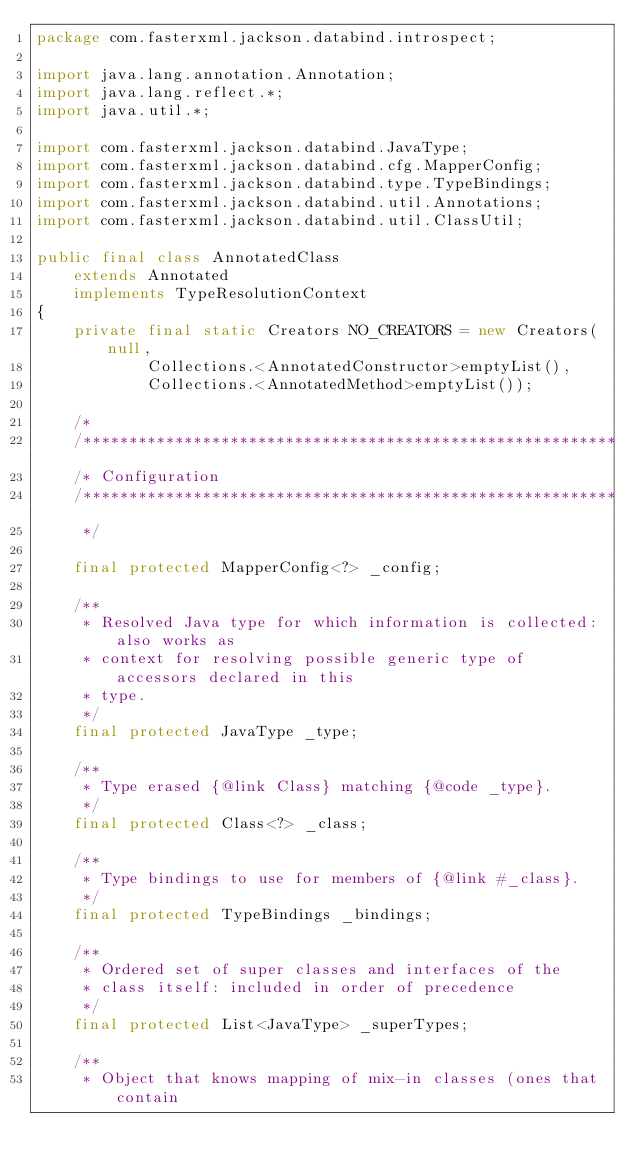Convert code to text. <code><loc_0><loc_0><loc_500><loc_500><_Java_>package com.fasterxml.jackson.databind.introspect;

import java.lang.annotation.Annotation;
import java.lang.reflect.*;
import java.util.*;

import com.fasterxml.jackson.databind.JavaType;
import com.fasterxml.jackson.databind.cfg.MapperConfig;
import com.fasterxml.jackson.databind.type.TypeBindings;
import com.fasterxml.jackson.databind.util.Annotations;
import com.fasterxml.jackson.databind.util.ClassUtil;

public final class AnnotatedClass
    extends Annotated
    implements TypeResolutionContext
{
    private final static Creators NO_CREATORS = new Creators(null,
            Collections.<AnnotatedConstructor>emptyList(),
            Collections.<AnnotatedMethod>emptyList());

    /*
    /**********************************************************
    /* Configuration
    /**********************************************************
     */

    final protected MapperConfig<?> _config;

    /**
     * Resolved Java type for which information is collected: also works as
     * context for resolving possible generic type of accessors declared in this
     * type.
     */
    final protected JavaType _type;

    /**
     * Type erased {@link Class} matching {@code _type}.
     */
    final protected Class<?> _class;

    /**
     * Type bindings to use for members of {@link #_class}.
     */
    final protected TypeBindings _bindings;

    /**
     * Ordered set of super classes and interfaces of the
     * class itself: included in order of precedence
     */
    final protected List<JavaType> _superTypes;

    /**
     * Object that knows mapping of mix-in classes (ones that contain</code> 